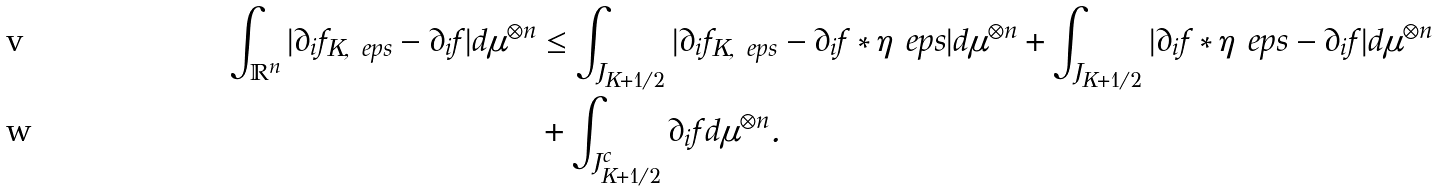Convert formula to latex. <formula><loc_0><loc_0><loc_500><loc_500>\int _ { \mathbb { R } ^ { n } } | \partial _ { i } f _ { K , \ e p s } - \partial _ { i } f | d \mu ^ { \otimes n } & \leq \int _ { J _ { K + 1 / 2 } } | \partial _ { i } f _ { K , \ e p s } - \partial _ { i } f * \eta _ { \ } e p s | d \mu ^ { \otimes n } + \int _ { J _ { K + 1 / 2 } } | \partial _ { i } f * \eta _ { \ } e p s - \partial _ { i } f | d \mu ^ { \otimes n } \\ & + \int _ { J _ { K + 1 / 2 } ^ { c } } \partial _ { i } f d \mu ^ { \otimes n } .</formula> 